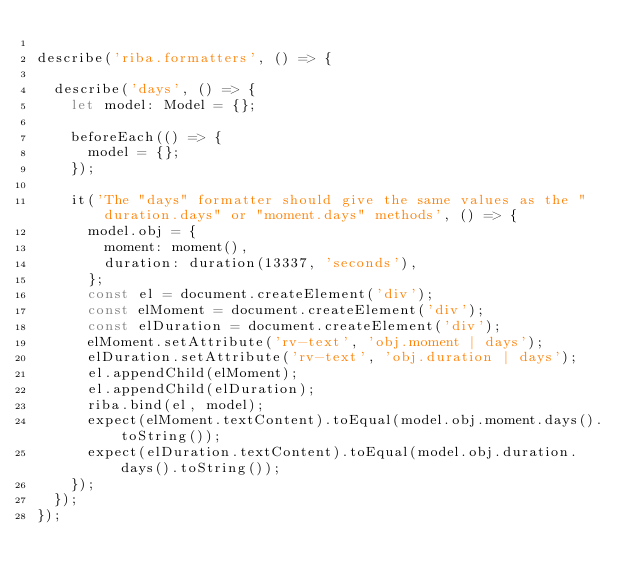<code> <loc_0><loc_0><loc_500><loc_500><_TypeScript_>
describe('riba.formatters', () => {

  describe('days', () => {
    let model: Model = {};

    beforeEach(() => {
      model = {};
    });

    it('The "days" formatter should give the same values as the "duration.days" or "moment.days" methods', () => {
      model.obj = {
        moment: moment(),
        duration: duration(13337, 'seconds'),
      };
      const el = document.createElement('div');
      const elMoment = document.createElement('div');
      const elDuration = document.createElement('div');
      elMoment.setAttribute('rv-text', 'obj.moment | days');
      elDuration.setAttribute('rv-text', 'obj.duration | days');
      el.appendChild(elMoment);
      el.appendChild(elDuration);
      riba.bind(el, model);
      expect(elMoment.textContent).toEqual(model.obj.moment.days().toString());
      expect(elDuration.textContent).toEqual(model.obj.duration.days().toString());
    });
  });
});
</code> 